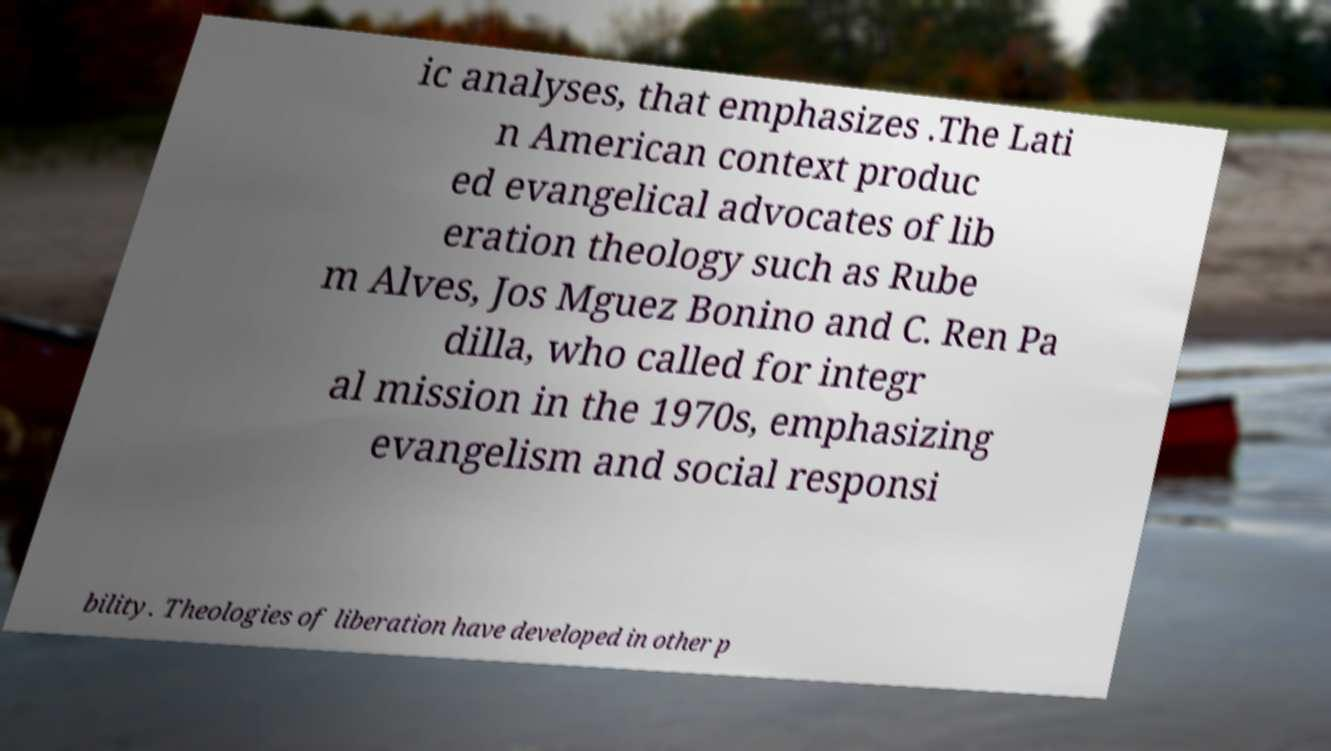Please read and relay the text visible in this image. What does it say? ic analyses, that emphasizes .The Lati n American context produc ed evangelical advocates of lib eration theology such as Rube m Alves, Jos Mguez Bonino and C. Ren Pa dilla, who called for integr al mission in the 1970s, emphasizing evangelism and social responsi bility. Theologies of liberation have developed in other p 